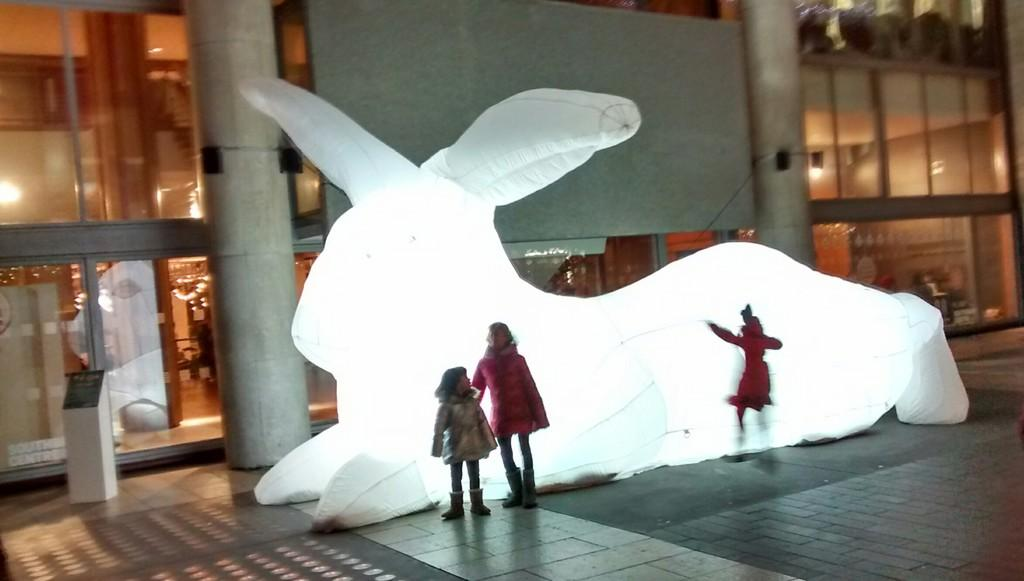What is the white object in the image that might be a statue? There is a white color object, possibly a statue, in the image. What architectural features can be seen in the image? There are pillars in the image. Who or what is present in the image? There are persons in the image. What object is used for speeches or presentations in the image? There is a podium in the image. What can be seen in the background of the image? There is a building and a board in the background of the image. What invention is being demonstrated by the persons in the image? There is no invention being demonstrated in the image; it only shows a statue, pillars, persons, a podium, a building, and a board. What story is being told by the persons in the image? There is no story being told in the image; it only shows a statue, pillars, persons, a podium, a building, and a board. 